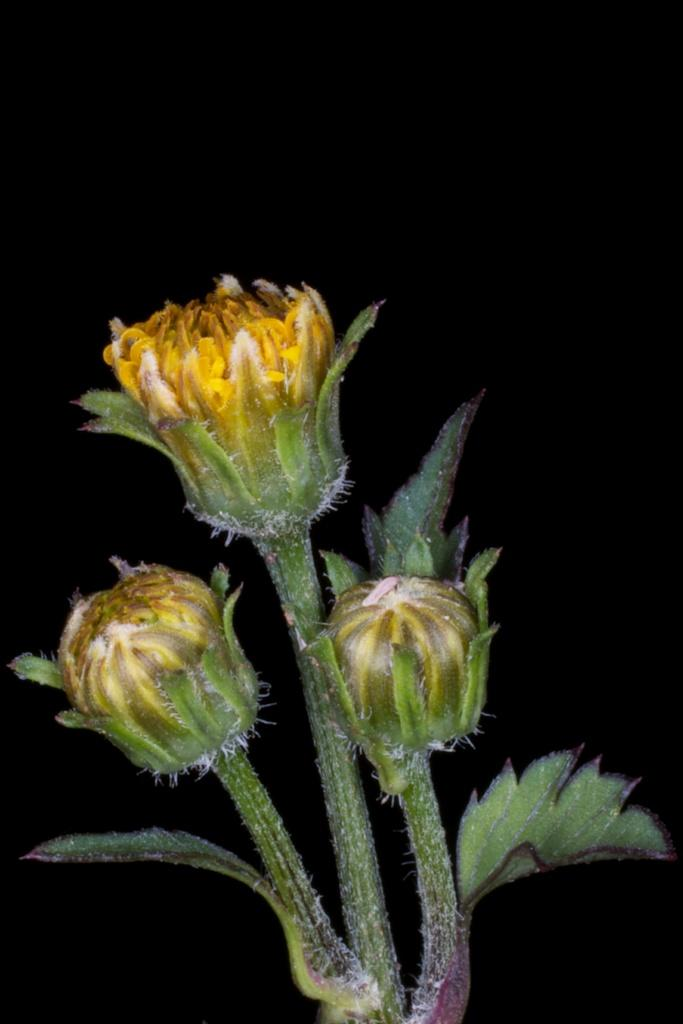What type of living organisms can be seen in the image? There are flowers and a plant visible in the image. Can you describe the plant in the image? Unfortunately, the provided facts do not give enough information to describe the plant in detail. What is the color of the flowers in the image? The color of the flowers in the image is not mentioned in the provided facts. Is the plant sinking in quicksand in the image? There is no quicksand present in the image, and therefore the plant is not sinking in it. What type of snow can be seen on the flowers in the image? There is no snow present in the image, so the flowers are not covered in it. 